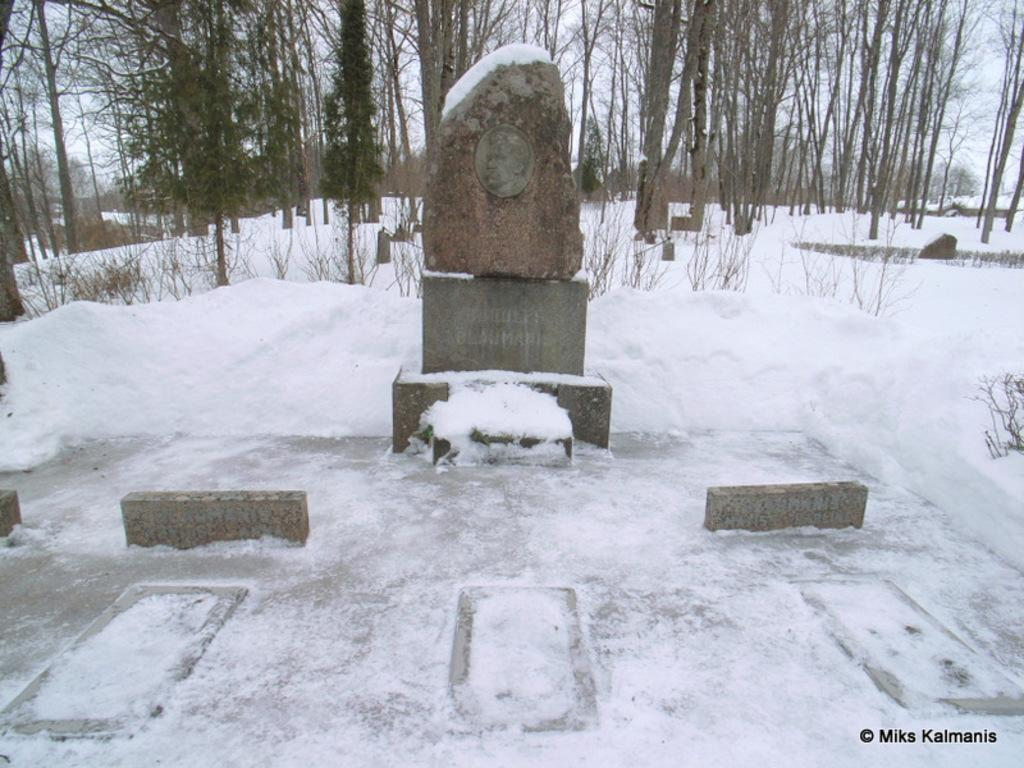What is covering the ground in the image? There is snow on the ground in the image. What type of vegetation can be seen in the image? There are trees in the image. What type of garden can be seen in the image? There is no garden present in the image; it features snow on the ground and trees. What type of drug is visible in the image? There is no drug present in the image. 